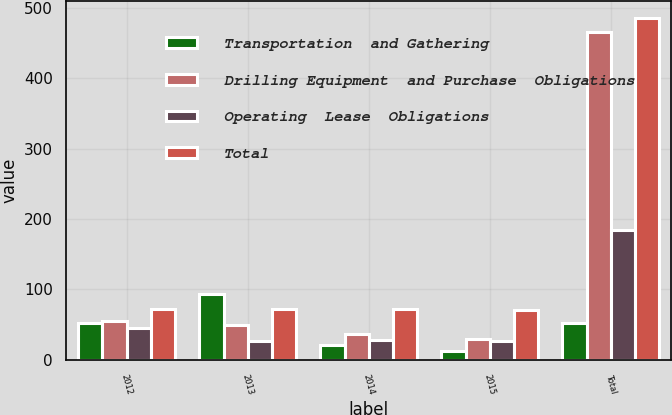<chart> <loc_0><loc_0><loc_500><loc_500><stacked_bar_chart><ecel><fcel>2012<fcel>2013<fcel>2014<fcel>2015<fcel>Total<nl><fcel>Transportation  and Gathering<fcel>52<fcel>93<fcel>21<fcel>13<fcel>52<nl><fcel>Drilling Equipment  and Purchase  Obligations<fcel>55<fcel>49<fcel>37<fcel>29<fcel>466<nl><fcel>Operating  Lease  Obligations<fcel>45<fcel>27<fcel>28<fcel>27<fcel>185<nl><fcel>Total<fcel>72<fcel>72<fcel>72<fcel>70<fcel>486<nl></chart> 